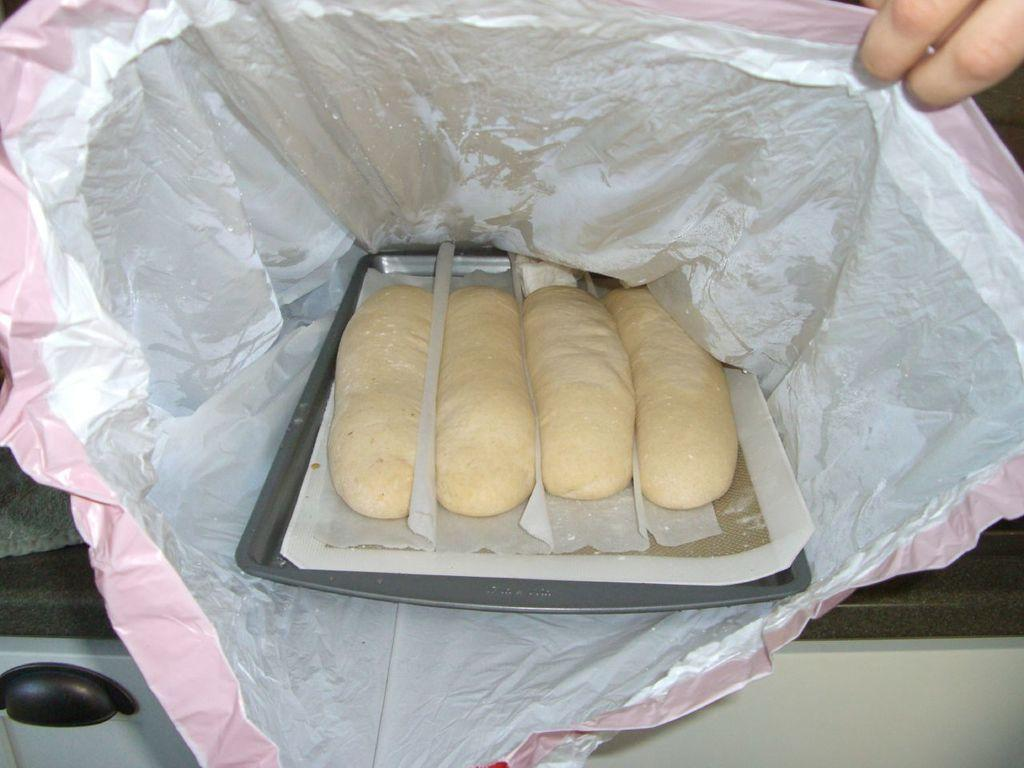What is the main subject in the center of the image? There is food in the center of the image. Can you describe any other elements in the image? There are fingers of a person visible on the right side of the image. What direction is the sidewalk facing in the image? There is no sidewalk present in the image. What type of attack is being carried out in the image? There is no attack or any indication of violence in the image. 